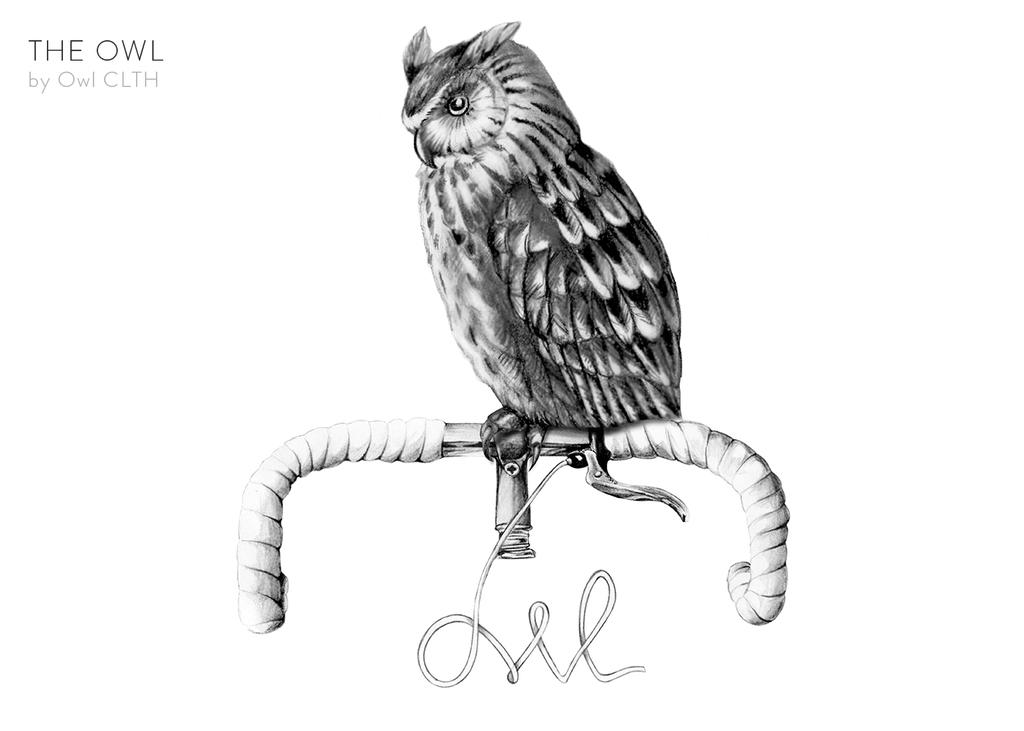What is the main subject of the painting in the image? The painting features an owl. What is the owl doing in the painting? The owl is standing on a pipe. Is there any text or symbol present in the painting? Yes, there is a watermark in the top left corner of the painting. What type of army uniform is the owl wearing in the painting? There is no army uniform or any clothing on the owl in the painting; it is a bird. What type of blade is the owl holding in the painting? There is no blade or any object in the owl's possession in the painting; it is simply standing on a pipe. 